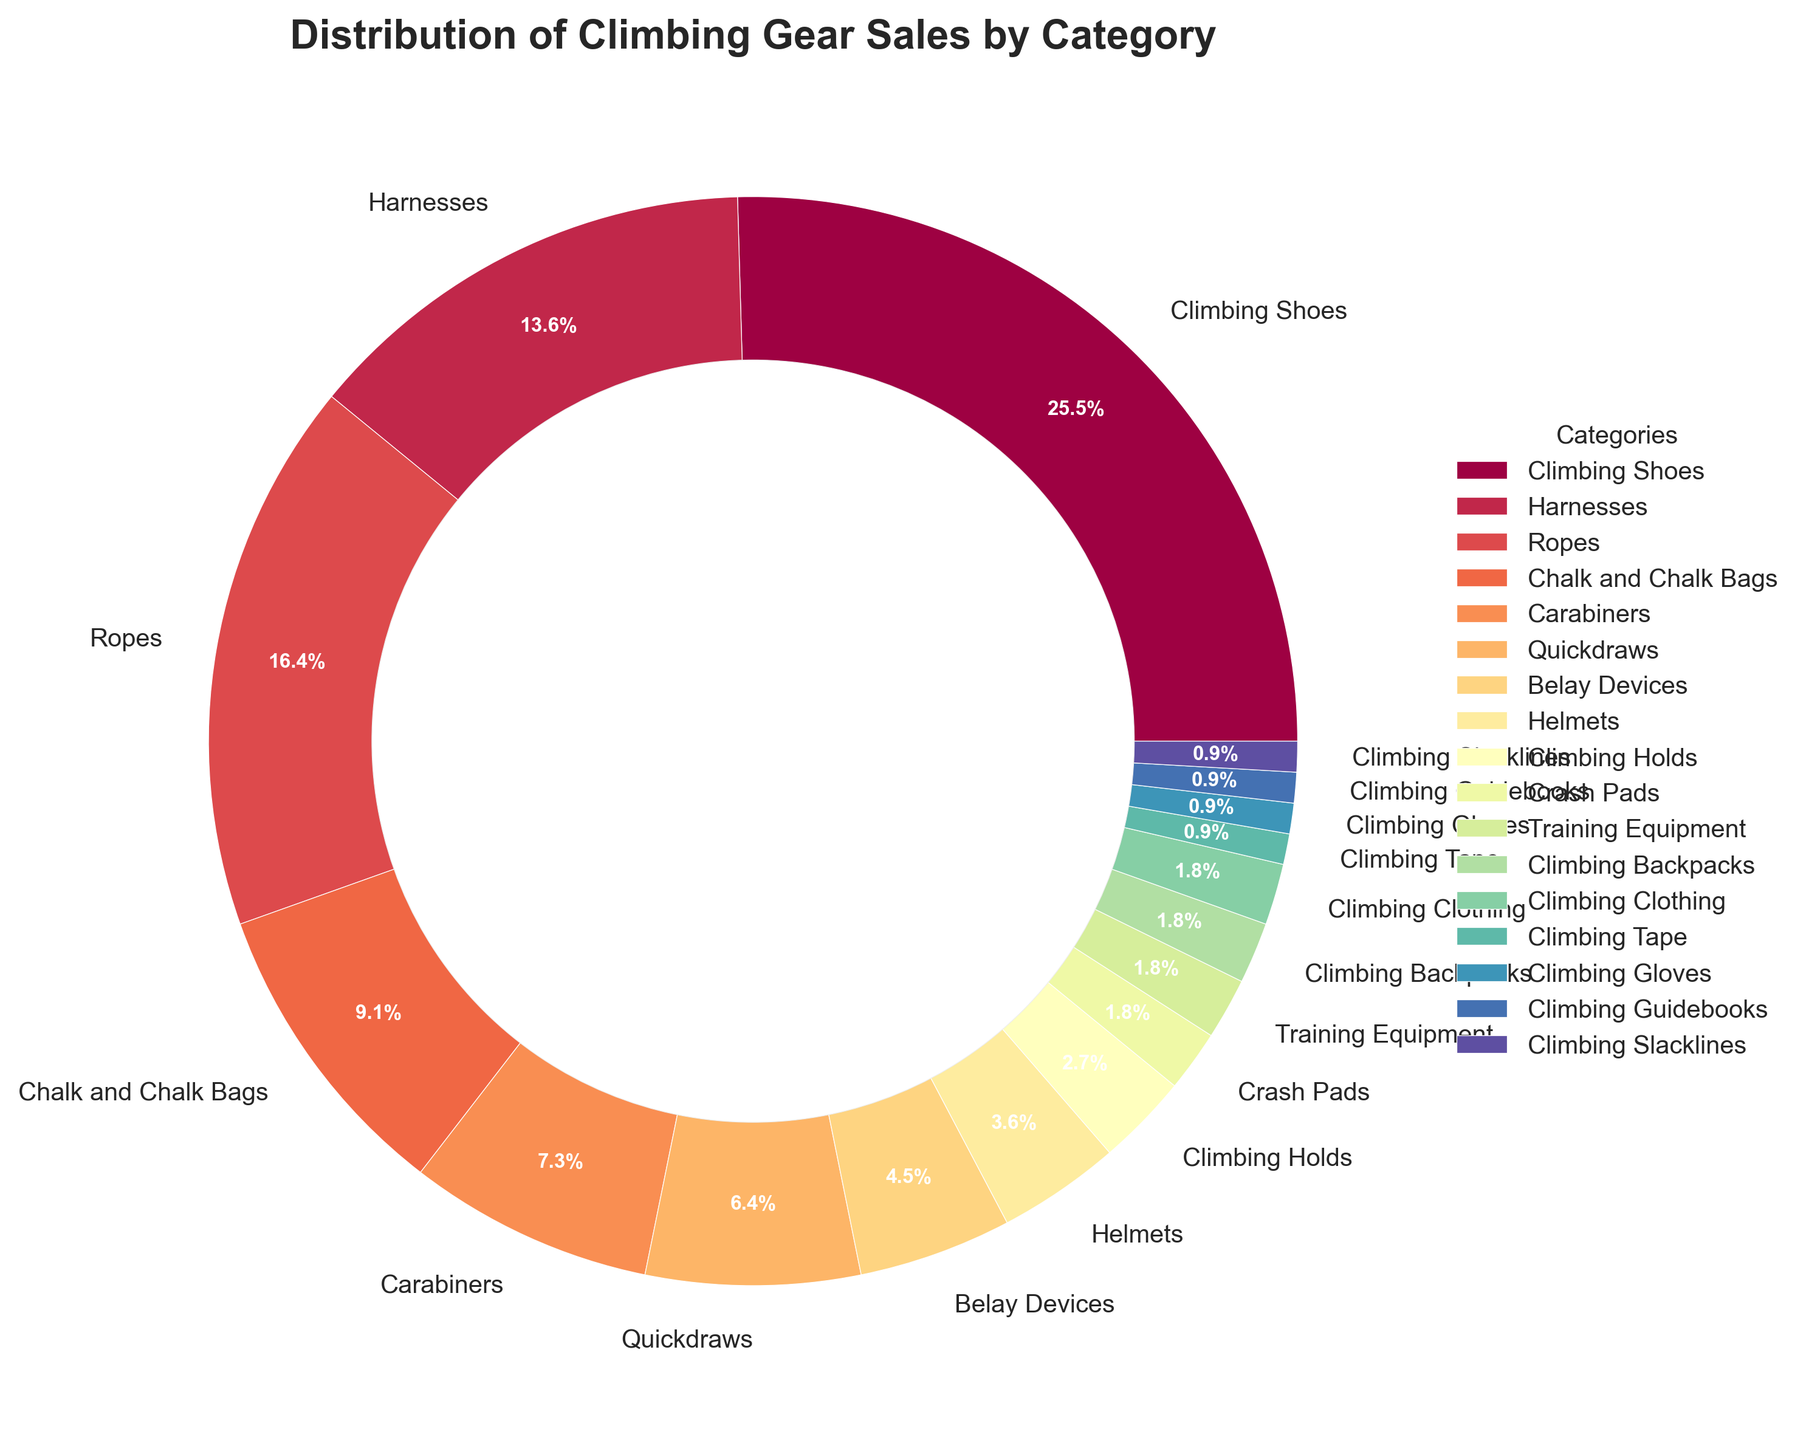What's the largest category in the climbing gear sales distribution? To find the largest category, we look at the slice with the biggest percentage. The "Climbing Shoes" slice has the largest value at 28%.
Answer: Climbing Shoes Which category contributes the least to climbing gear sales? The smallest value in the pie chart is the smallest slice, which has a percentage of 1%. There are multiple categories with 1% (Climbing Tape, Climbing Gloves, Climbing Guidebooks, Climbing Slacklines).
Answer: Climbing Tape, Climbing Gloves, Climbing Guidebooks, Climbing Slacklines How much more percentage do Climbing Shoes contribute compared to Ropes? Climbing Shoes contribute 28% and Ropes contribute 18%. Calculating the difference: 28% - 18% = 10%.
Answer: 10% What percentage of climbing gear sales is accounted for by Chalk and Chalk Bags, Carabiners, and Quickdraws together? Sum the percentages of these three categories: Chalk and Chalk Bags (10%) + Carabiners (8%) + Quickdraws (7%) = 10% + 8% + 7% = 25%.
Answer: 25% Which category has a higher sales percentage, Helmets or Belay Devices? Helmets have a 4% slice, and Belay Devices have a 5% slice. 5% is greater than 4%.
Answer: Belay Devices Are Ropes or Harnesses a larger portion of sales, and by how much? Comparing the percentages of Ropes (18%) and Harnesses (15%), the difference is 18% - 15% = 3%.
Answer: Ropes, by 3% How does the percentage of sales for Climbing Shoes compare to the combined sales of the smallest four categories? Climbing Shoes are at 28%. The smallest four categories (Crash Pads, Training Equipment, Climbing Backpacks, Climbing Clothing each at 2%): 2% + 2% + 2% + 2% = 8%. 28% is significantly more than 8%.
Answer: Climbing Shoes are 20% more What is the combined sales percentage for the top three categories? The top three categories are Climbing Shoes (28%), Harnesses (15%), and Ropes (18%). Their combined sales percentage is 28% + 15% + 18% = 61%.
Answer: 61% Which categories share the same percentage of sales and what is that percentage? The categories with the same percentage are Training Equipment, Climbing Backpacks, Climbing Clothing, each at 2%.
Answer: Training Equipment, Climbing Backpacks, Climbing Clothing, 2% Between Chalk and Chalk Bags and Carabiners, which one contributes a higher percentage, and by how much? Chalk and Chalk Bags contribute 10%, and Carabiners contribute 8%. The difference is 10% - 8% = 2%.
Answer: Chalk and Chalk Bags, by 2% 